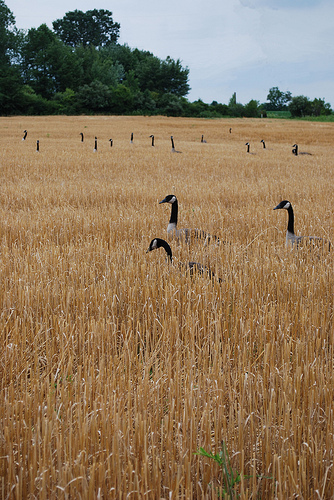<image>
Can you confirm if the grass is next to the goose? No. The grass is not positioned next to the goose. They are located in different areas of the scene. Where is the goose in relation to the grass? Is it next to the grass? No. The goose is not positioned next to the grass. They are located in different areas of the scene. 